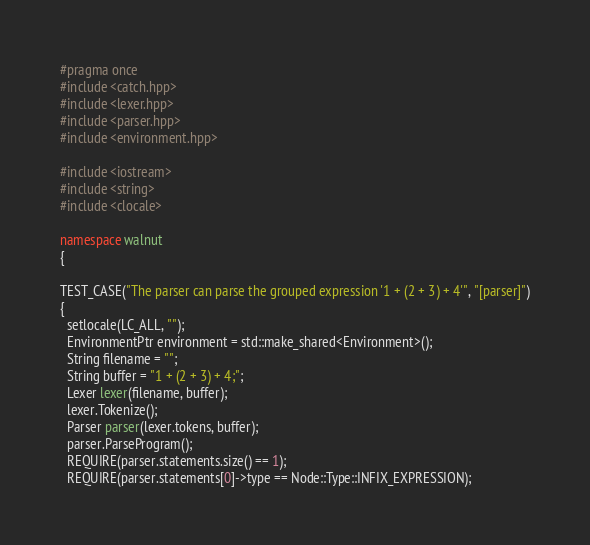<code> <loc_0><loc_0><loc_500><loc_500><_C++_>#pragma once
#include <catch.hpp>
#include <lexer.hpp>
#include <parser.hpp>
#include <environment.hpp>

#include <iostream>
#include <string>
#include <clocale>

namespace walnut
{

TEST_CASE("The parser can parse the grouped expression '1 + (2 + 3) + 4'", "[parser]")
{
  setlocale(LC_ALL, "");
  EnvironmentPtr environment = std::make_shared<Environment>();
  String filename = "";
  String buffer = "1 + (2 + 3) + 4;";
  Lexer lexer(filename, buffer);
  lexer.Tokenize();
  Parser parser(lexer.tokens, buffer);
  parser.ParseProgram();
  REQUIRE(parser.statements.size() == 1);
  REQUIRE(parser.statements[0]->type == Node::Type::INFIX_EXPRESSION);</code> 